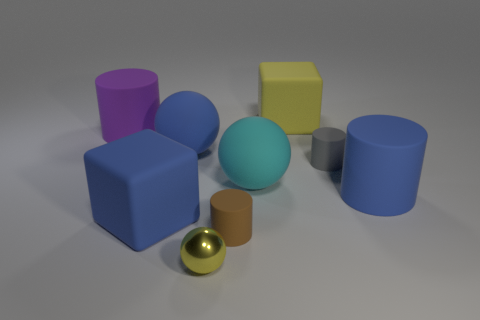Subtract all yellow cylinders. Subtract all blue cubes. How many cylinders are left? 4 Add 1 tiny purple objects. How many objects exist? 10 Subtract all cylinders. How many objects are left? 5 Subtract all red shiny balls. Subtract all small brown cylinders. How many objects are left? 8 Add 5 big blue rubber cubes. How many big blue rubber cubes are left? 6 Add 1 green metal objects. How many green metal objects exist? 1 Subtract 0 purple balls. How many objects are left? 9 